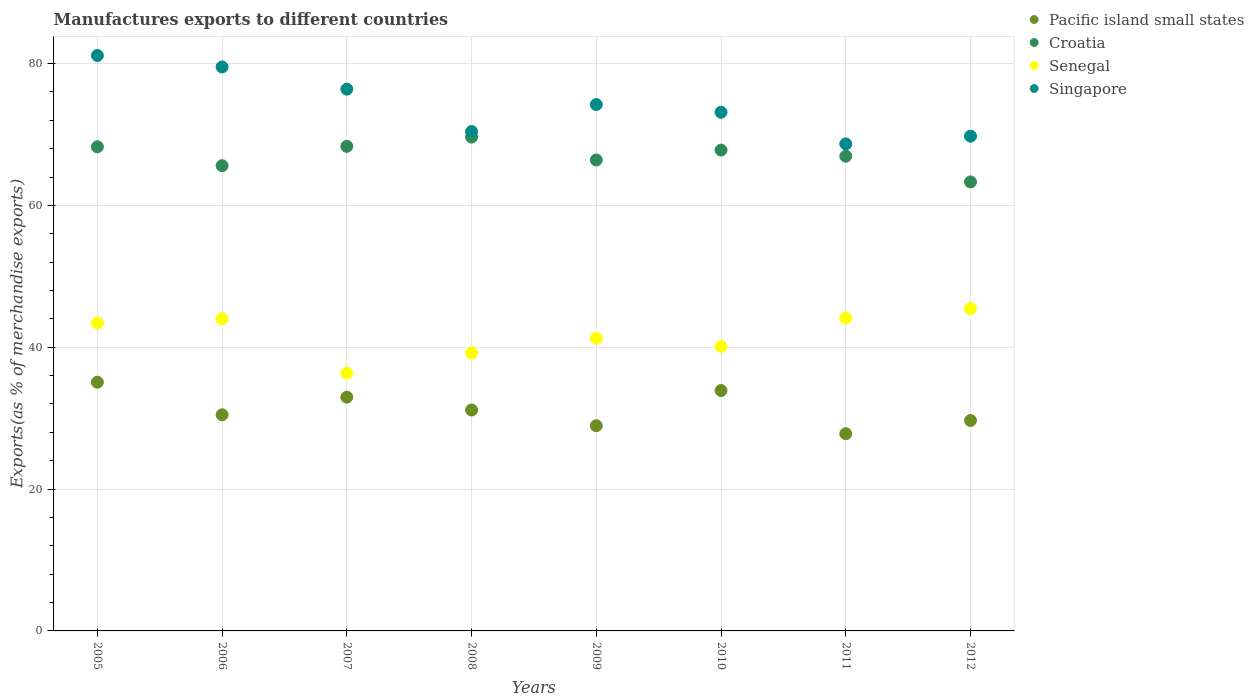How many different coloured dotlines are there?
Offer a very short reply. 4. Is the number of dotlines equal to the number of legend labels?
Offer a terse response. Yes. What is the percentage of exports to different countries in Singapore in 2008?
Make the answer very short. 70.42. Across all years, what is the maximum percentage of exports to different countries in Singapore?
Provide a short and direct response. 81.14. Across all years, what is the minimum percentage of exports to different countries in Senegal?
Make the answer very short. 36.35. What is the total percentage of exports to different countries in Croatia in the graph?
Your response must be concise. 536.26. What is the difference between the percentage of exports to different countries in Croatia in 2008 and that in 2011?
Ensure brevity in your answer.  2.69. What is the difference between the percentage of exports to different countries in Pacific island small states in 2006 and the percentage of exports to different countries in Senegal in 2012?
Provide a succinct answer. -14.97. What is the average percentage of exports to different countries in Croatia per year?
Offer a terse response. 67.03. In the year 2010, what is the difference between the percentage of exports to different countries in Singapore and percentage of exports to different countries in Pacific island small states?
Offer a very short reply. 39.23. What is the ratio of the percentage of exports to different countries in Singapore in 2007 to that in 2009?
Your response must be concise. 1.03. Is the percentage of exports to different countries in Pacific island small states in 2008 less than that in 2009?
Provide a short and direct response. No. What is the difference between the highest and the second highest percentage of exports to different countries in Singapore?
Make the answer very short. 1.62. What is the difference between the highest and the lowest percentage of exports to different countries in Pacific island small states?
Your answer should be very brief. 7.26. Is the sum of the percentage of exports to different countries in Singapore in 2006 and 2009 greater than the maximum percentage of exports to different countries in Pacific island small states across all years?
Ensure brevity in your answer.  Yes. Is it the case that in every year, the sum of the percentage of exports to different countries in Croatia and percentage of exports to different countries in Senegal  is greater than the sum of percentage of exports to different countries in Pacific island small states and percentage of exports to different countries in Singapore?
Offer a very short reply. Yes. Is it the case that in every year, the sum of the percentage of exports to different countries in Senegal and percentage of exports to different countries in Croatia  is greater than the percentage of exports to different countries in Singapore?
Provide a succinct answer. Yes. Is the percentage of exports to different countries in Pacific island small states strictly less than the percentage of exports to different countries in Croatia over the years?
Offer a very short reply. Yes. What is the difference between two consecutive major ticks on the Y-axis?
Your answer should be compact. 20. Are the values on the major ticks of Y-axis written in scientific E-notation?
Offer a terse response. No. Does the graph contain any zero values?
Offer a very short reply. No. Does the graph contain grids?
Offer a very short reply. Yes. How are the legend labels stacked?
Your answer should be very brief. Vertical. What is the title of the graph?
Offer a very short reply. Manufactures exports to different countries. What is the label or title of the X-axis?
Offer a very short reply. Years. What is the label or title of the Y-axis?
Ensure brevity in your answer.  Exports(as % of merchandise exports). What is the Exports(as % of merchandise exports) in Pacific island small states in 2005?
Your response must be concise. 35.07. What is the Exports(as % of merchandise exports) in Croatia in 2005?
Keep it short and to the point. 68.26. What is the Exports(as % of merchandise exports) of Senegal in 2005?
Offer a very short reply. 43.42. What is the Exports(as % of merchandise exports) of Singapore in 2005?
Offer a terse response. 81.14. What is the Exports(as % of merchandise exports) in Pacific island small states in 2006?
Offer a very short reply. 30.48. What is the Exports(as % of merchandise exports) of Croatia in 2006?
Offer a terse response. 65.6. What is the Exports(as % of merchandise exports) in Senegal in 2006?
Offer a terse response. 44.01. What is the Exports(as % of merchandise exports) of Singapore in 2006?
Your answer should be compact. 79.52. What is the Exports(as % of merchandise exports) of Pacific island small states in 2007?
Keep it short and to the point. 32.96. What is the Exports(as % of merchandise exports) of Croatia in 2007?
Your response must be concise. 68.32. What is the Exports(as % of merchandise exports) in Senegal in 2007?
Provide a short and direct response. 36.35. What is the Exports(as % of merchandise exports) of Singapore in 2007?
Provide a succinct answer. 76.39. What is the Exports(as % of merchandise exports) in Pacific island small states in 2008?
Your response must be concise. 31.14. What is the Exports(as % of merchandise exports) in Croatia in 2008?
Give a very brief answer. 69.63. What is the Exports(as % of merchandise exports) of Senegal in 2008?
Ensure brevity in your answer.  39.19. What is the Exports(as % of merchandise exports) of Singapore in 2008?
Provide a short and direct response. 70.42. What is the Exports(as % of merchandise exports) of Pacific island small states in 2009?
Ensure brevity in your answer.  28.94. What is the Exports(as % of merchandise exports) of Croatia in 2009?
Ensure brevity in your answer.  66.4. What is the Exports(as % of merchandise exports) of Senegal in 2009?
Your answer should be very brief. 41.28. What is the Exports(as % of merchandise exports) in Singapore in 2009?
Provide a short and direct response. 74.22. What is the Exports(as % of merchandise exports) of Pacific island small states in 2010?
Provide a succinct answer. 33.9. What is the Exports(as % of merchandise exports) of Croatia in 2010?
Offer a terse response. 67.8. What is the Exports(as % of merchandise exports) of Senegal in 2010?
Your answer should be compact. 40.12. What is the Exports(as % of merchandise exports) in Singapore in 2010?
Your answer should be very brief. 73.13. What is the Exports(as % of merchandise exports) in Pacific island small states in 2011?
Your response must be concise. 27.81. What is the Exports(as % of merchandise exports) of Croatia in 2011?
Ensure brevity in your answer.  66.94. What is the Exports(as % of merchandise exports) of Senegal in 2011?
Provide a succinct answer. 44.11. What is the Exports(as % of merchandise exports) in Singapore in 2011?
Offer a terse response. 68.67. What is the Exports(as % of merchandise exports) of Pacific island small states in 2012?
Your response must be concise. 29.67. What is the Exports(as % of merchandise exports) of Croatia in 2012?
Your answer should be compact. 63.31. What is the Exports(as % of merchandise exports) of Senegal in 2012?
Ensure brevity in your answer.  45.44. What is the Exports(as % of merchandise exports) of Singapore in 2012?
Your answer should be compact. 69.76. Across all years, what is the maximum Exports(as % of merchandise exports) in Pacific island small states?
Your response must be concise. 35.07. Across all years, what is the maximum Exports(as % of merchandise exports) of Croatia?
Your response must be concise. 69.63. Across all years, what is the maximum Exports(as % of merchandise exports) of Senegal?
Provide a short and direct response. 45.44. Across all years, what is the maximum Exports(as % of merchandise exports) of Singapore?
Make the answer very short. 81.14. Across all years, what is the minimum Exports(as % of merchandise exports) in Pacific island small states?
Keep it short and to the point. 27.81. Across all years, what is the minimum Exports(as % of merchandise exports) of Croatia?
Ensure brevity in your answer.  63.31. Across all years, what is the minimum Exports(as % of merchandise exports) in Senegal?
Your answer should be very brief. 36.35. Across all years, what is the minimum Exports(as % of merchandise exports) of Singapore?
Make the answer very short. 68.67. What is the total Exports(as % of merchandise exports) in Pacific island small states in the graph?
Keep it short and to the point. 249.96. What is the total Exports(as % of merchandise exports) of Croatia in the graph?
Your answer should be compact. 536.26. What is the total Exports(as % of merchandise exports) in Senegal in the graph?
Provide a short and direct response. 333.92. What is the total Exports(as % of merchandise exports) in Singapore in the graph?
Ensure brevity in your answer.  593.24. What is the difference between the Exports(as % of merchandise exports) of Pacific island small states in 2005 and that in 2006?
Offer a very short reply. 4.59. What is the difference between the Exports(as % of merchandise exports) of Croatia in 2005 and that in 2006?
Ensure brevity in your answer.  2.66. What is the difference between the Exports(as % of merchandise exports) of Senegal in 2005 and that in 2006?
Ensure brevity in your answer.  -0.59. What is the difference between the Exports(as % of merchandise exports) in Singapore in 2005 and that in 2006?
Your answer should be compact. 1.62. What is the difference between the Exports(as % of merchandise exports) in Pacific island small states in 2005 and that in 2007?
Offer a terse response. 2.11. What is the difference between the Exports(as % of merchandise exports) of Croatia in 2005 and that in 2007?
Offer a terse response. -0.06. What is the difference between the Exports(as % of merchandise exports) in Senegal in 2005 and that in 2007?
Your answer should be compact. 7.07. What is the difference between the Exports(as % of merchandise exports) in Singapore in 2005 and that in 2007?
Your answer should be very brief. 4.75. What is the difference between the Exports(as % of merchandise exports) in Pacific island small states in 2005 and that in 2008?
Give a very brief answer. 3.93. What is the difference between the Exports(as % of merchandise exports) of Croatia in 2005 and that in 2008?
Offer a very short reply. -1.37. What is the difference between the Exports(as % of merchandise exports) in Senegal in 2005 and that in 2008?
Provide a succinct answer. 4.24. What is the difference between the Exports(as % of merchandise exports) of Singapore in 2005 and that in 2008?
Offer a very short reply. 10.72. What is the difference between the Exports(as % of merchandise exports) in Pacific island small states in 2005 and that in 2009?
Provide a succinct answer. 6.13. What is the difference between the Exports(as % of merchandise exports) of Croatia in 2005 and that in 2009?
Your answer should be very brief. 1.86. What is the difference between the Exports(as % of merchandise exports) in Senegal in 2005 and that in 2009?
Your answer should be compact. 2.15. What is the difference between the Exports(as % of merchandise exports) of Singapore in 2005 and that in 2009?
Your answer should be very brief. 6.92. What is the difference between the Exports(as % of merchandise exports) in Pacific island small states in 2005 and that in 2010?
Your answer should be compact. 1.17. What is the difference between the Exports(as % of merchandise exports) in Croatia in 2005 and that in 2010?
Provide a succinct answer. 0.46. What is the difference between the Exports(as % of merchandise exports) in Senegal in 2005 and that in 2010?
Your answer should be compact. 3.31. What is the difference between the Exports(as % of merchandise exports) of Singapore in 2005 and that in 2010?
Provide a succinct answer. 8.01. What is the difference between the Exports(as % of merchandise exports) in Pacific island small states in 2005 and that in 2011?
Your answer should be compact. 7.26. What is the difference between the Exports(as % of merchandise exports) in Croatia in 2005 and that in 2011?
Your response must be concise. 1.32. What is the difference between the Exports(as % of merchandise exports) in Senegal in 2005 and that in 2011?
Your response must be concise. -0.69. What is the difference between the Exports(as % of merchandise exports) in Singapore in 2005 and that in 2011?
Your answer should be very brief. 12.47. What is the difference between the Exports(as % of merchandise exports) in Pacific island small states in 2005 and that in 2012?
Provide a short and direct response. 5.4. What is the difference between the Exports(as % of merchandise exports) in Croatia in 2005 and that in 2012?
Your answer should be very brief. 4.95. What is the difference between the Exports(as % of merchandise exports) of Senegal in 2005 and that in 2012?
Your response must be concise. -2.02. What is the difference between the Exports(as % of merchandise exports) of Singapore in 2005 and that in 2012?
Make the answer very short. 11.37. What is the difference between the Exports(as % of merchandise exports) in Pacific island small states in 2006 and that in 2007?
Offer a very short reply. -2.49. What is the difference between the Exports(as % of merchandise exports) of Croatia in 2006 and that in 2007?
Your answer should be compact. -2.72. What is the difference between the Exports(as % of merchandise exports) in Senegal in 2006 and that in 2007?
Make the answer very short. 7.66. What is the difference between the Exports(as % of merchandise exports) of Singapore in 2006 and that in 2007?
Your answer should be very brief. 3.13. What is the difference between the Exports(as % of merchandise exports) of Pacific island small states in 2006 and that in 2008?
Provide a succinct answer. -0.67. What is the difference between the Exports(as % of merchandise exports) of Croatia in 2006 and that in 2008?
Your answer should be very brief. -4.03. What is the difference between the Exports(as % of merchandise exports) in Senegal in 2006 and that in 2008?
Keep it short and to the point. 4.82. What is the difference between the Exports(as % of merchandise exports) of Singapore in 2006 and that in 2008?
Keep it short and to the point. 9.1. What is the difference between the Exports(as % of merchandise exports) in Pacific island small states in 2006 and that in 2009?
Your response must be concise. 1.54. What is the difference between the Exports(as % of merchandise exports) in Croatia in 2006 and that in 2009?
Provide a short and direct response. -0.8. What is the difference between the Exports(as % of merchandise exports) of Senegal in 2006 and that in 2009?
Offer a terse response. 2.73. What is the difference between the Exports(as % of merchandise exports) in Singapore in 2006 and that in 2009?
Offer a terse response. 5.3. What is the difference between the Exports(as % of merchandise exports) in Pacific island small states in 2006 and that in 2010?
Provide a succinct answer. -3.42. What is the difference between the Exports(as % of merchandise exports) in Croatia in 2006 and that in 2010?
Your response must be concise. -2.2. What is the difference between the Exports(as % of merchandise exports) in Senegal in 2006 and that in 2010?
Make the answer very short. 3.89. What is the difference between the Exports(as % of merchandise exports) of Singapore in 2006 and that in 2010?
Your answer should be compact. 6.39. What is the difference between the Exports(as % of merchandise exports) of Pacific island small states in 2006 and that in 2011?
Keep it short and to the point. 2.67. What is the difference between the Exports(as % of merchandise exports) in Croatia in 2006 and that in 2011?
Make the answer very short. -1.34. What is the difference between the Exports(as % of merchandise exports) of Senegal in 2006 and that in 2011?
Keep it short and to the point. -0.1. What is the difference between the Exports(as % of merchandise exports) of Singapore in 2006 and that in 2011?
Make the answer very short. 10.85. What is the difference between the Exports(as % of merchandise exports) of Pacific island small states in 2006 and that in 2012?
Provide a succinct answer. 0.81. What is the difference between the Exports(as % of merchandise exports) of Croatia in 2006 and that in 2012?
Provide a succinct answer. 2.29. What is the difference between the Exports(as % of merchandise exports) of Senegal in 2006 and that in 2012?
Your answer should be very brief. -1.44. What is the difference between the Exports(as % of merchandise exports) of Singapore in 2006 and that in 2012?
Provide a short and direct response. 9.76. What is the difference between the Exports(as % of merchandise exports) of Pacific island small states in 2007 and that in 2008?
Offer a very short reply. 1.82. What is the difference between the Exports(as % of merchandise exports) of Croatia in 2007 and that in 2008?
Your response must be concise. -1.3. What is the difference between the Exports(as % of merchandise exports) in Senegal in 2007 and that in 2008?
Your answer should be compact. -2.83. What is the difference between the Exports(as % of merchandise exports) in Singapore in 2007 and that in 2008?
Your response must be concise. 5.97. What is the difference between the Exports(as % of merchandise exports) in Pacific island small states in 2007 and that in 2009?
Provide a short and direct response. 4.02. What is the difference between the Exports(as % of merchandise exports) of Croatia in 2007 and that in 2009?
Your answer should be compact. 1.92. What is the difference between the Exports(as % of merchandise exports) in Senegal in 2007 and that in 2009?
Your response must be concise. -4.92. What is the difference between the Exports(as % of merchandise exports) of Singapore in 2007 and that in 2009?
Provide a succinct answer. 2.17. What is the difference between the Exports(as % of merchandise exports) of Pacific island small states in 2007 and that in 2010?
Offer a very short reply. -0.94. What is the difference between the Exports(as % of merchandise exports) in Croatia in 2007 and that in 2010?
Offer a terse response. 0.53. What is the difference between the Exports(as % of merchandise exports) in Senegal in 2007 and that in 2010?
Provide a short and direct response. -3.76. What is the difference between the Exports(as % of merchandise exports) of Singapore in 2007 and that in 2010?
Provide a short and direct response. 3.26. What is the difference between the Exports(as % of merchandise exports) in Pacific island small states in 2007 and that in 2011?
Provide a succinct answer. 5.16. What is the difference between the Exports(as % of merchandise exports) of Croatia in 2007 and that in 2011?
Give a very brief answer. 1.38. What is the difference between the Exports(as % of merchandise exports) in Senegal in 2007 and that in 2011?
Give a very brief answer. -7.76. What is the difference between the Exports(as % of merchandise exports) in Singapore in 2007 and that in 2011?
Your answer should be compact. 7.72. What is the difference between the Exports(as % of merchandise exports) in Pacific island small states in 2007 and that in 2012?
Offer a terse response. 3.3. What is the difference between the Exports(as % of merchandise exports) of Croatia in 2007 and that in 2012?
Your response must be concise. 5.01. What is the difference between the Exports(as % of merchandise exports) in Senegal in 2007 and that in 2012?
Your response must be concise. -9.09. What is the difference between the Exports(as % of merchandise exports) of Singapore in 2007 and that in 2012?
Provide a short and direct response. 6.63. What is the difference between the Exports(as % of merchandise exports) in Pacific island small states in 2008 and that in 2009?
Offer a very short reply. 2.21. What is the difference between the Exports(as % of merchandise exports) in Croatia in 2008 and that in 2009?
Give a very brief answer. 3.22. What is the difference between the Exports(as % of merchandise exports) of Senegal in 2008 and that in 2009?
Keep it short and to the point. -2.09. What is the difference between the Exports(as % of merchandise exports) in Singapore in 2008 and that in 2009?
Keep it short and to the point. -3.8. What is the difference between the Exports(as % of merchandise exports) in Pacific island small states in 2008 and that in 2010?
Provide a short and direct response. -2.75. What is the difference between the Exports(as % of merchandise exports) in Croatia in 2008 and that in 2010?
Your answer should be very brief. 1.83. What is the difference between the Exports(as % of merchandise exports) of Senegal in 2008 and that in 2010?
Your answer should be compact. -0.93. What is the difference between the Exports(as % of merchandise exports) of Singapore in 2008 and that in 2010?
Keep it short and to the point. -2.71. What is the difference between the Exports(as % of merchandise exports) of Pacific island small states in 2008 and that in 2011?
Your answer should be compact. 3.34. What is the difference between the Exports(as % of merchandise exports) of Croatia in 2008 and that in 2011?
Offer a very short reply. 2.69. What is the difference between the Exports(as % of merchandise exports) in Senegal in 2008 and that in 2011?
Offer a terse response. -4.92. What is the difference between the Exports(as % of merchandise exports) of Singapore in 2008 and that in 2011?
Give a very brief answer. 1.75. What is the difference between the Exports(as % of merchandise exports) in Pacific island small states in 2008 and that in 2012?
Your answer should be compact. 1.48. What is the difference between the Exports(as % of merchandise exports) in Croatia in 2008 and that in 2012?
Make the answer very short. 6.31. What is the difference between the Exports(as % of merchandise exports) of Senegal in 2008 and that in 2012?
Your answer should be compact. -6.26. What is the difference between the Exports(as % of merchandise exports) in Singapore in 2008 and that in 2012?
Your response must be concise. 0.66. What is the difference between the Exports(as % of merchandise exports) of Pacific island small states in 2009 and that in 2010?
Provide a short and direct response. -4.96. What is the difference between the Exports(as % of merchandise exports) of Croatia in 2009 and that in 2010?
Ensure brevity in your answer.  -1.39. What is the difference between the Exports(as % of merchandise exports) in Senegal in 2009 and that in 2010?
Make the answer very short. 1.16. What is the difference between the Exports(as % of merchandise exports) of Singapore in 2009 and that in 2010?
Offer a very short reply. 1.09. What is the difference between the Exports(as % of merchandise exports) of Pacific island small states in 2009 and that in 2011?
Provide a short and direct response. 1.13. What is the difference between the Exports(as % of merchandise exports) in Croatia in 2009 and that in 2011?
Keep it short and to the point. -0.54. What is the difference between the Exports(as % of merchandise exports) in Senegal in 2009 and that in 2011?
Ensure brevity in your answer.  -2.83. What is the difference between the Exports(as % of merchandise exports) in Singapore in 2009 and that in 2011?
Your answer should be very brief. 5.55. What is the difference between the Exports(as % of merchandise exports) in Pacific island small states in 2009 and that in 2012?
Your answer should be compact. -0.73. What is the difference between the Exports(as % of merchandise exports) of Croatia in 2009 and that in 2012?
Offer a very short reply. 3.09. What is the difference between the Exports(as % of merchandise exports) in Senegal in 2009 and that in 2012?
Provide a succinct answer. -4.17. What is the difference between the Exports(as % of merchandise exports) in Singapore in 2009 and that in 2012?
Make the answer very short. 4.46. What is the difference between the Exports(as % of merchandise exports) in Pacific island small states in 2010 and that in 2011?
Offer a very short reply. 6.09. What is the difference between the Exports(as % of merchandise exports) of Croatia in 2010 and that in 2011?
Offer a terse response. 0.86. What is the difference between the Exports(as % of merchandise exports) of Senegal in 2010 and that in 2011?
Provide a succinct answer. -3.99. What is the difference between the Exports(as % of merchandise exports) of Singapore in 2010 and that in 2011?
Your response must be concise. 4.46. What is the difference between the Exports(as % of merchandise exports) in Pacific island small states in 2010 and that in 2012?
Offer a terse response. 4.23. What is the difference between the Exports(as % of merchandise exports) in Croatia in 2010 and that in 2012?
Give a very brief answer. 4.49. What is the difference between the Exports(as % of merchandise exports) in Senegal in 2010 and that in 2012?
Provide a short and direct response. -5.33. What is the difference between the Exports(as % of merchandise exports) of Singapore in 2010 and that in 2012?
Make the answer very short. 3.37. What is the difference between the Exports(as % of merchandise exports) in Pacific island small states in 2011 and that in 2012?
Keep it short and to the point. -1.86. What is the difference between the Exports(as % of merchandise exports) in Croatia in 2011 and that in 2012?
Ensure brevity in your answer.  3.63. What is the difference between the Exports(as % of merchandise exports) of Senegal in 2011 and that in 2012?
Keep it short and to the point. -1.33. What is the difference between the Exports(as % of merchandise exports) of Singapore in 2011 and that in 2012?
Offer a very short reply. -1.09. What is the difference between the Exports(as % of merchandise exports) in Pacific island small states in 2005 and the Exports(as % of merchandise exports) in Croatia in 2006?
Give a very brief answer. -30.53. What is the difference between the Exports(as % of merchandise exports) in Pacific island small states in 2005 and the Exports(as % of merchandise exports) in Senegal in 2006?
Provide a succinct answer. -8.94. What is the difference between the Exports(as % of merchandise exports) of Pacific island small states in 2005 and the Exports(as % of merchandise exports) of Singapore in 2006?
Ensure brevity in your answer.  -44.45. What is the difference between the Exports(as % of merchandise exports) in Croatia in 2005 and the Exports(as % of merchandise exports) in Senegal in 2006?
Keep it short and to the point. 24.25. What is the difference between the Exports(as % of merchandise exports) in Croatia in 2005 and the Exports(as % of merchandise exports) in Singapore in 2006?
Provide a succinct answer. -11.26. What is the difference between the Exports(as % of merchandise exports) in Senegal in 2005 and the Exports(as % of merchandise exports) in Singapore in 2006?
Provide a succinct answer. -36.1. What is the difference between the Exports(as % of merchandise exports) in Pacific island small states in 2005 and the Exports(as % of merchandise exports) in Croatia in 2007?
Offer a very short reply. -33.25. What is the difference between the Exports(as % of merchandise exports) of Pacific island small states in 2005 and the Exports(as % of merchandise exports) of Senegal in 2007?
Your response must be concise. -1.28. What is the difference between the Exports(as % of merchandise exports) in Pacific island small states in 2005 and the Exports(as % of merchandise exports) in Singapore in 2007?
Give a very brief answer. -41.32. What is the difference between the Exports(as % of merchandise exports) in Croatia in 2005 and the Exports(as % of merchandise exports) in Senegal in 2007?
Provide a short and direct response. 31.91. What is the difference between the Exports(as % of merchandise exports) in Croatia in 2005 and the Exports(as % of merchandise exports) in Singapore in 2007?
Keep it short and to the point. -8.13. What is the difference between the Exports(as % of merchandise exports) in Senegal in 2005 and the Exports(as % of merchandise exports) in Singapore in 2007?
Offer a very short reply. -32.96. What is the difference between the Exports(as % of merchandise exports) of Pacific island small states in 2005 and the Exports(as % of merchandise exports) of Croatia in 2008?
Provide a succinct answer. -34.56. What is the difference between the Exports(as % of merchandise exports) in Pacific island small states in 2005 and the Exports(as % of merchandise exports) in Senegal in 2008?
Provide a short and direct response. -4.12. What is the difference between the Exports(as % of merchandise exports) of Pacific island small states in 2005 and the Exports(as % of merchandise exports) of Singapore in 2008?
Offer a very short reply. -35.35. What is the difference between the Exports(as % of merchandise exports) in Croatia in 2005 and the Exports(as % of merchandise exports) in Senegal in 2008?
Make the answer very short. 29.07. What is the difference between the Exports(as % of merchandise exports) of Croatia in 2005 and the Exports(as % of merchandise exports) of Singapore in 2008?
Offer a terse response. -2.16. What is the difference between the Exports(as % of merchandise exports) in Senegal in 2005 and the Exports(as % of merchandise exports) in Singapore in 2008?
Your answer should be very brief. -27. What is the difference between the Exports(as % of merchandise exports) of Pacific island small states in 2005 and the Exports(as % of merchandise exports) of Croatia in 2009?
Ensure brevity in your answer.  -31.33. What is the difference between the Exports(as % of merchandise exports) in Pacific island small states in 2005 and the Exports(as % of merchandise exports) in Senegal in 2009?
Offer a terse response. -6.21. What is the difference between the Exports(as % of merchandise exports) of Pacific island small states in 2005 and the Exports(as % of merchandise exports) of Singapore in 2009?
Keep it short and to the point. -39.15. What is the difference between the Exports(as % of merchandise exports) in Croatia in 2005 and the Exports(as % of merchandise exports) in Senegal in 2009?
Your answer should be very brief. 26.98. What is the difference between the Exports(as % of merchandise exports) in Croatia in 2005 and the Exports(as % of merchandise exports) in Singapore in 2009?
Make the answer very short. -5.96. What is the difference between the Exports(as % of merchandise exports) of Senegal in 2005 and the Exports(as % of merchandise exports) of Singapore in 2009?
Make the answer very short. -30.79. What is the difference between the Exports(as % of merchandise exports) in Pacific island small states in 2005 and the Exports(as % of merchandise exports) in Croatia in 2010?
Ensure brevity in your answer.  -32.73. What is the difference between the Exports(as % of merchandise exports) in Pacific island small states in 2005 and the Exports(as % of merchandise exports) in Senegal in 2010?
Your response must be concise. -5.05. What is the difference between the Exports(as % of merchandise exports) in Pacific island small states in 2005 and the Exports(as % of merchandise exports) in Singapore in 2010?
Provide a short and direct response. -38.06. What is the difference between the Exports(as % of merchandise exports) of Croatia in 2005 and the Exports(as % of merchandise exports) of Senegal in 2010?
Your response must be concise. 28.14. What is the difference between the Exports(as % of merchandise exports) in Croatia in 2005 and the Exports(as % of merchandise exports) in Singapore in 2010?
Your response must be concise. -4.87. What is the difference between the Exports(as % of merchandise exports) in Senegal in 2005 and the Exports(as % of merchandise exports) in Singapore in 2010?
Provide a short and direct response. -29.71. What is the difference between the Exports(as % of merchandise exports) of Pacific island small states in 2005 and the Exports(as % of merchandise exports) of Croatia in 2011?
Offer a terse response. -31.87. What is the difference between the Exports(as % of merchandise exports) in Pacific island small states in 2005 and the Exports(as % of merchandise exports) in Senegal in 2011?
Your response must be concise. -9.04. What is the difference between the Exports(as % of merchandise exports) in Pacific island small states in 2005 and the Exports(as % of merchandise exports) in Singapore in 2011?
Provide a succinct answer. -33.6. What is the difference between the Exports(as % of merchandise exports) in Croatia in 2005 and the Exports(as % of merchandise exports) in Senegal in 2011?
Offer a very short reply. 24.15. What is the difference between the Exports(as % of merchandise exports) in Croatia in 2005 and the Exports(as % of merchandise exports) in Singapore in 2011?
Give a very brief answer. -0.41. What is the difference between the Exports(as % of merchandise exports) in Senegal in 2005 and the Exports(as % of merchandise exports) in Singapore in 2011?
Provide a succinct answer. -25.25. What is the difference between the Exports(as % of merchandise exports) in Pacific island small states in 2005 and the Exports(as % of merchandise exports) in Croatia in 2012?
Your answer should be very brief. -28.24. What is the difference between the Exports(as % of merchandise exports) in Pacific island small states in 2005 and the Exports(as % of merchandise exports) in Senegal in 2012?
Offer a very short reply. -10.37. What is the difference between the Exports(as % of merchandise exports) of Pacific island small states in 2005 and the Exports(as % of merchandise exports) of Singapore in 2012?
Make the answer very short. -34.69. What is the difference between the Exports(as % of merchandise exports) in Croatia in 2005 and the Exports(as % of merchandise exports) in Senegal in 2012?
Provide a succinct answer. 22.81. What is the difference between the Exports(as % of merchandise exports) in Croatia in 2005 and the Exports(as % of merchandise exports) in Singapore in 2012?
Give a very brief answer. -1.5. What is the difference between the Exports(as % of merchandise exports) in Senegal in 2005 and the Exports(as % of merchandise exports) in Singapore in 2012?
Offer a terse response. -26.34. What is the difference between the Exports(as % of merchandise exports) in Pacific island small states in 2006 and the Exports(as % of merchandise exports) in Croatia in 2007?
Ensure brevity in your answer.  -37.85. What is the difference between the Exports(as % of merchandise exports) of Pacific island small states in 2006 and the Exports(as % of merchandise exports) of Senegal in 2007?
Provide a succinct answer. -5.88. What is the difference between the Exports(as % of merchandise exports) of Pacific island small states in 2006 and the Exports(as % of merchandise exports) of Singapore in 2007?
Provide a succinct answer. -45.91. What is the difference between the Exports(as % of merchandise exports) of Croatia in 2006 and the Exports(as % of merchandise exports) of Senegal in 2007?
Provide a succinct answer. 29.25. What is the difference between the Exports(as % of merchandise exports) of Croatia in 2006 and the Exports(as % of merchandise exports) of Singapore in 2007?
Make the answer very short. -10.79. What is the difference between the Exports(as % of merchandise exports) in Senegal in 2006 and the Exports(as % of merchandise exports) in Singapore in 2007?
Offer a terse response. -32.38. What is the difference between the Exports(as % of merchandise exports) in Pacific island small states in 2006 and the Exports(as % of merchandise exports) in Croatia in 2008?
Give a very brief answer. -39.15. What is the difference between the Exports(as % of merchandise exports) of Pacific island small states in 2006 and the Exports(as % of merchandise exports) of Senegal in 2008?
Offer a terse response. -8.71. What is the difference between the Exports(as % of merchandise exports) of Pacific island small states in 2006 and the Exports(as % of merchandise exports) of Singapore in 2008?
Offer a very short reply. -39.94. What is the difference between the Exports(as % of merchandise exports) in Croatia in 2006 and the Exports(as % of merchandise exports) in Senegal in 2008?
Ensure brevity in your answer.  26.41. What is the difference between the Exports(as % of merchandise exports) in Croatia in 2006 and the Exports(as % of merchandise exports) in Singapore in 2008?
Ensure brevity in your answer.  -4.82. What is the difference between the Exports(as % of merchandise exports) of Senegal in 2006 and the Exports(as % of merchandise exports) of Singapore in 2008?
Offer a very short reply. -26.41. What is the difference between the Exports(as % of merchandise exports) of Pacific island small states in 2006 and the Exports(as % of merchandise exports) of Croatia in 2009?
Your response must be concise. -35.93. What is the difference between the Exports(as % of merchandise exports) of Pacific island small states in 2006 and the Exports(as % of merchandise exports) of Senegal in 2009?
Make the answer very short. -10.8. What is the difference between the Exports(as % of merchandise exports) in Pacific island small states in 2006 and the Exports(as % of merchandise exports) in Singapore in 2009?
Ensure brevity in your answer.  -43.74. What is the difference between the Exports(as % of merchandise exports) in Croatia in 2006 and the Exports(as % of merchandise exports) in Senegal in 2009?
Offer a terse response. 24.32. What is the difference between the Exports(as % of merchandise exports) in Croatia in 2006 and the Exports(as % of merchandise exports) in Singapore in 2009?
Give a very brief answer. -8.62. What is the difference between the Exports(as % of merchandise exports) of Senegal in 2006 and the Exports(as % of merchandise exports) of Singapore in 2009?
Give a very brief answer. -30.21. What is the difference between the Exports(as % of merchandise exports) of Pacific island small states in 2006 and the Exports(as % of merchandise exports) of Croatia in 2010?
Your answer should be very brief. -37.32. What is the difference between the Exports(as % of merchandise exports) of Pacific island small states in 2006 and the Exports(as % of merchandise exports) of Senegal in 2010?
Your answer should be very brief. -9.64. What is the difference between the Exports(as % of merchandise exports) in Pacific island small states in 2006 and the Exports(as % of merchandise exports) in Singapore in 2010?
Keep it short and to the point. -42.65. What is the difference between the Exports(as % of merchandise exports) in Croatia in 2006 and the Exports(as % of merchandise exports) in Senegal in 2010?
Make the answer very short. 25.48. What is the difference between the Exports(as % of merchandise exports) in Croatia in 2006 and the Exports(as % of merchandise exports) in Singapore in 2010?
Your response must be concise. -7.53. What is the difference between the Exports(as % of merchandise exports) in Senegal in 2006 and the Exports(as % of merchandise exports) in Singapore in 2010?
Offer a very short reply. -29.12. What is the difference between the Exports(as % of merchandise exports) of Pacific island small states in 2006 and the Exports(as % of merchandise exports) of Croatia in 2011?
Give a very brief answer. -36.46. What is the difference between the Exports(as % of merchandise exports) of Pacific island small states in 2006 and the Exports(as % of merchandise exports) of Senegal in 2011?
Your answer should be compact. -13.63. What is the difference between the Exports(as % of merchandise exports) of Pacific island small states in 2006 and the Exports(as % of merchandise exports) of Singapore in 2011?
Provide a short and direct response. -38.19. What is the difference between the Exports(as % of merchandise exports) in Croatia in 2006 and the Exports(as % of merchandise exports) in Senegal in 2011?
Provide a short and direct response. 21.49. What is the difference between the Exports(as % of merchandise exports) in Croatia in 2006 and the Exports(as % of merchandise exports) in Singapore in 2011?
Ensure brevity in your answer.  -3.07. What is the difference between the Exports(as % of merchandise exports) of Senegal in 2006 and the Exports(as % of merchandise exports) of Singapore in 2011?
Keep it short and to the point. -24.66. What is the difference between the Exports(as % of merchandise exports) of Pacific island small states in 2006 and the Exports(as % of merchandise exports) of Croatia in 2012?
Provide a short and direct response. -32.84. What is the difference between the Exports(as % of merchandise exports) of Pacific island small states in 2006 and the Exports(as % of merchandise exports) of Senegal in 2012?
Give a very brief answer. -14.97. What is the difference between the Exports(as % of merchandise exports) of Pacific island small states in 2006 and the Exports(as % of merchandise exports) of Singapore in 2012?
Keep it short and to the point. -39.29. What is the difference between the Exports(as % of merchandise exports) of Croatia in 2006 and the Exports(as % of merchandise exports) of Senegal in 2012?
Provide a short and direct response. 20.16. What is the difference between the Exports(as % of merchandise exports) of Croatia in 2006 and the Exports(as % of merchandise exports) of Singapore in 2012?
Keep it short and to the point. -4.16. What is the difference between the Exports(as % of merchandise exports) of Senegal in 2006 and the Exports(as % of merchandise exports) of Singapore in 2012?
Keep it short and to the point. -25.75. What is the difference between the Exports(as % of merchandise exports) of Pacific island small states in 2007 and the Exports(as % of merchandise exports) of Croatia in 2008?
Keep it short and to the point. -36.67. What is the difference between the Exports(as % of merchandise exports) in Pacific island small states in 2007 and the Exports(as % of merchandise exports) in Senegal in 2008?
Offer a terse response. -6.22. What is the difference between the Exports(as % of merchandise exports) of Pacific island small states in 2007 and the Exports(as % of merchandise exports) of Singapore in 2008?
Provide a succinct answer. -37.46. What is the difference between the Exports(as % of merchandise exports) in Croatia in 2007 and the Exports(as % of merchandise exports) in Senegal in 2008?
Keep it short and to the point. 29.14. What is the difference between the Exports(as % of merchandise exports) in Croatia in 2007 and the Exports(as % of merchandise exports) in Singapore in 2008?
Make the answer very short. -2.1. What is the difference between the Exports(as % of merchandise exports) in Senegal in 2007 and the Exports(as % of merchandise exports) in Singapore in 2008?
Offer a very short reply. -34.07. What is the difference between the Exports(as % of merchandise exports) of Pacific island small states in 2007 and the Exports(as % of merchandise exports) of Croatia in 2009?
Provide a short and direct response. -33.44. What is the difference between the Exports(as % of merchandise exports) of Pacific island small states in 2007 and the Exports(as % of merchandise exports) of Senegal in 2009?
Offer a terse response. -8.32. What is the difference between the Exports(as % of merchandise exports) in Pacific island small states in 2007 and the Exports(as % of merchandise exports) in Singapore in 2009?
Your response must be concise. -41.26. What is the difference between the Exports(as % of merchandise exports) in Croatia in 2007 and the Exports(as % of merchandise exports) in Senegal in 2009?
Your answer should be compact. 27.05. What is the difference between the Exports(as % of merchandise exports) in Croatia in 2007 and the Exports(as % of merchandise exports) in Singapore in 2009?
Keep it short and to the point. -5.89. What is the difference between the Exports(as % of merchandise exports) of Senegal in 2007 and the Exports(as % of merchandise exports) of Singapore in 2009?
Offer a terse response. -37.86. What is the difference between the Exports(as % of merchandise exports) in Pacific island small states in 2007 and the Exports(as % of merchandise exports) in Croatia in 2010?
Provide a succinct answer. -34.84. What is the difference between the Exports(as % of merchandise exports) in Pacific island small states in 2007 and the Exports(as % of merchandise exports) in Senegal in 2010?
Make the answer very short. -7.16. What is the difference between the Exports(as % of merchandise exports) of Pacific island small states in 2007 and the Exports(as % of merchandise exports) of Singapore in 2010?
Ensure brevity in your answer.  -40.17. What is the difference between the Exports(as % of merchandise exports) of Croatia in 2007 and the Exports(as % of merchandise exports) of Senegal in 2010?
Provide a short and direct response. 28.21. What is the difference between the Exports(as % of merchandise exports) in Croatia in 2007 and the Exports(as % of merchandise exports) in Singapore in 2010?
Provide a short and direct response. -4.81. What is the difference between the Exports(as % of merchandise exports) in Senegal in 2007 and the Exports(as % of merchandise exports) in Singapore in 2010?
Your answer should be compact. -36.78. What is the difference between the Exports(as % of merchandise exports) of Pacific island small states in 2007 and the Exports(as % of merchandise exports) of Croatia in 2011?
Offer a terse response. -33.98. What is the difference between the Exports(as % of merchandise exports) of Pacific island small states in 2007 and the Exports(as % of merchandise exports) of Senegal in 2011?
Ensure brevity in your answer.  -11.15. What is the difference between the Exports(as % of merchandise exports) of Pacific island small states in 2007 and the Exports(as % of merchandise exports) of Singapore in 2011?
Make the answer very short. -35.71. What is the difference between the Exports(as % of merchandise exports) in Croatia in 2007 and the Exports(as % of merchandise exports) in Senegal in 2011?
Ensure brevity in your answer.  24.21. What is the difference between the Exports(as % of merchandise exports) of Croatia in 2007 and the Exports(as % of merchandise exports) of Singapore in 2011?
Offer a terse response. -0.35. What is the difference between the Exports(as % of merchandise exports) of Senegal in 2007 and the Exports(as % of merchandise exports) of Singapore in 2011?
Provide a succinct answer. -32.32. What is the difference between the Exports(as % of merchandise exports) of Pacific island small states in 2007 and the Exports(as % of merchandise exports) of Croatia in 2012?
Make the answer very short. -30.35. What is the difference between the Exports(as % of merchandise exports) of Pacific island small states in 2007 and the Exports(as % of merchandise exports) of Senegal in 2012?
Keep it short and to the point. -12.48. What is the difference between the Exports(as % of merchandise exports) in Pacific island small states in 2007 and the Exports(as % of merchandise exports) in Singapore in 2012?
Your answer should be compact. -36.8. What is the difference between the Exports(as % of merchandise exports) of Croatia in 2007 and the Exports(as % of merchandise exports) of Senegal in 2012?
Offer a terse response. 22.88. What is the difference between the Exports(as % of merchandise exports) in Croatia in 2007 and the Exports(as % of merchandise exports) in Singapore in 2012?
Offer a terse response. -1.44. What is the difference between the Exports(as % of merchandise exports) in Senegal in 2007 and the Exports(as % of merchandise exports) in Singapore in 2012?
Your answer should be very brief. -33.41. What is the difference between the Exports(as % of merchandise exports) in Pacific island small states in 2008 and the Exports(as % of merchandise exports) in Croatia in 2009?
Give a very brief answer. -35.26. What is the difference between the Exports(as % of merchandise exports) of Pacific island small states in 2008 and the Exports(as % of merchandise exports) of Senegal in 2009?
Provide a short and direct response. -10.13. What is the difference between the Exports(as % of merchandise exports) in Pacific island small states in 2008 and the Exports(as % of merchandise exports) in Singapore in 2009?
Give a very brief answer. -43.07. What is the difference between the Exports(as % of merchandise exports) in Croatia in 2008 and the Exports(as % of merchandise exports) in Senegal in 2009?
Your answer should be compact. 28.35. What is the difference between the Exports(as % of merchandise exports) of Croatia in 2008 and the Exports(as % of merchandise exports) of Singapore in 2009?
Your response must be concise. -4.59. What is the difference between the Exports(as % of merchandise exports) of Senegal in 2008 and the Exports(as % of merchandise exports) of Singapore in 2009?
Make the answer very short. -35.03. What is the difference between the Exports(as % of merchandise exports) of Pacific island small states in 2008 and the Exports(as % of merchandise exports) of Croatia in 2010?
Provide a short and direct response. -36.65. What is the difference between the Exports(as % of merchandise exports) in Pacific island small states in 2008 and the Exports(as % of merchandise exports) in Senegal in 2010?
Your answer should be compact. -8.97. What is the difference between the Exports(as % of merchandise exports) of Pacific island small states in 2008 and the Exports(as % of merchandise exports) of Singapore in 2010?
Provide a succinct answer. -41.99. What is the difference between the Exports(as % of merchandise exports) of Croatia in 2008 and the Exports(as % of merchandise exports) of Senegal in 2010?
Offer a very short reply. 29.51. What is the difference between the Exports(as % of merchandise exports) of Croatia in 2008 and the Exports(as % of merchandise exports) of Singapore in 2010?
Give a very brief answer. -3.5. What is the difference between the Exports(as % of merchandise exports) of Senegal in 2008 and the Exports(as % of merchandise exports) of Singapore in 2010?
Make the answer very short. -33.94. What is the difference between the Exports(as % of merchandise exports) in Pacific island small states in 2008 and the Exports(as % of merchandise exports) in Croatia in 2011?
Your answer should be compact. -35.8. What is the difference between the Exports(as % of merchandise exports) of Pacific island small states in 2008 and the Exports(as % of merchandise exports) of Senegal in 2011?
Your answer should be compact. -12.97. What is the difference between the Exports(as % of merchandise exports) of Pacific island small states in 2008 and the Exports(as % of merchandise exports) of Singapore in 2011?
Provide a succinct answer. -37.53. What is the difference between the Exports(as % of merchandise exports) in Croatia in 2008 and the Exports(as % of merchandise exports) in Senegal in 2011?
Give a very brief answer. 25.52. What is the difference between the Exports(as % of merchandise exports) in Croatia in 2008 and the Exports(as % of merchandise exports) in Singapore in 2011?
Offer a terse response. 0.96. What is the difference between the Exports(as % of merchandise exports) in Senegal in 2008 and the Exports(as % of merchandise exports) in Singapore in 2011?
Provide a short and direct response. -29.48. What is the difference between the Exports(as % of merchandise exports) in Pacific island small states in 2008 and the Exports(as % of merchandise exports) in Croatia in 2012?
Your answer should be compact. -32.17. What is the difference between the Exports(as % of merchandise exports) in Pacific island small states in 2008 and the Exports(as % of merchandise exports) in Senegal in 2012?
Give a very brief answer. -14.3. What is the difference between the Exports(as % of merchandise exports) in Pacific island small states in 2008 and the Exports(as % of merchandise exports) in Singapore in 2012?
Make the answer very short. -38.62. What is the difference between the Exports(as % of merchandise exports) of Croatia in 2008 and the Exports(as % of merchandise exports) of Senegal in 2012?
Provide a short and direct response. 24.18. What is the difference between the Exports(as % of merchandise exports) of Croatia in 2008 and the Exports(as % of merchandise exports) of Singapore in 2012?
Ensure brevity in your answer.  -0.14. What is the difference between the Exports(as % of merchandise exports) in Senegal in 2008 and the Exports(as % of merchandise exports) in Singapore in 2012?
Your answer should be compact. -30.58. What is the difference between the Exports(as % of merchandise exports) of Pacific island small states in 2009 and the Exports(as % of merchandise exports) of Croatia in 2010?
Your answer should be compact. -38.86. What is the difference between the Exports(as % of merchandise exports) in Pacific island small states in 2009 and the Exports(as % of merchandise exports) in Senegal in 2010?
Your response must be concise. -11.18. What is the difference between the Exports(as % of merchandise exports) in Pacific island small states in 2009 and the Exports(as % of merchandise exports) in Singapore in 2010?
Provide a short and direct response. -44.19. What is the difference between the Exports(as % of merchandise exports) of Croatia in 2009 and the Exports(as % of merchandise exports) of Senegal in 2010?
Provide a succinct answer. 26.29. What is the difference between the Exports(as % of merchandise exports) of Croatia in 2009 and the Exports(as % of merchandise exports) of Singapore in 2010?
Your answer should be compact. -6.73. What is the difference between the Exports(as % of merchandise exports) in Senegal in 2009 and the Exports(as % of merchandise exports) in Singapore in 2010?
Your response must be concise. -31.85. What is the difference between the Exports(as % of merchandise exports) in Pacific island small states in 2009 and the Exports(as % of merchandise exports) in Croatia in 2011?
Offer a terse response. -38. What is the difference between the Exports(as % of merchandise exports) of Pacific island small states in 2009 and the Exports(as % of merchandise exports) of Senegal in 2011?
Provide a succinct answer. -15.17. What is the difference between the Exports(as % of merchandise exports) of Pacific island small states in 2009 and the Exports(as % of merchandise exports) of Singapore in 2011?
Your answer should be very brief. -39.73. What is the difference between the Exports(as % of merchandise exports) of Croatia in 2009 and the Exports(as % of merchandise exports) of Senegal in 2011?
Offer a very short reply. 22.29. What is the difference between the Exports(as % of merchandise exports) of Croatia in 2009 and the Exports(as % of merchandise exports) of Singapore in 2011?
Ensure brevity in your answer.  -2.27. What is the difference between the Exports(as % of merchandise exports) in Senegal in 2009 and the Exports(as % of merchandise exports) in Singapore in 2011?
Your answer should be compact. -27.39. What is the difference between the Exports(as % of merchandise exports) in Pacific island small states in 2009 and the Exports(as % of merchandise exports) in Croatia in 2012?
Offer a terse response. -34.38. What is the difference between the Exports(as % of merchandise exports) in Pacific island small states in 2009 and the Exports(as % of merchandise exports) in Senegal in 2012?
Provide a succinct answer. -16.51. What is the difference between the Exports(as % of merchandise exports) of Pacific island small states in 2009 and the Exports(as % of merchandise exports) of Singapore in 2012?
Provide a succinct answer. -40.83. What is the difference between the Exports(as % of merchandise exports) of Croatia in 2009 and the Exports(as % of merchandise exports) of Senegal in 2012?
Give a very brief answer. 20.96. What is the difference between the Exports(as % of merchandise exports) of Croatia in 2009 and the Exports(as % of merchandise exports) of Singapore in 2012?
Provide a succinct answer. -3.36. What is the difference between the Exports(as % of merchandise exports) of Senegal in 2009 and the Exports(as % of merchandise exports) of Singapore in 2012?
Ensure brevity in your answer.  -28.49. What is the difference between the Exports(as % of merchandise exports) in Pacific island small states in 2010 and the Exports(as % of merchandise exports) in Croatia in 2011?
Your answer should be very brief. -33.04. What is the difference between the Exports(as % of merchandise exports) in Pacific island small states in 2010 and the Exports(as % of merchandise exports) in Senegal in 2011?
Make the answer very short. -10.21. What is the difference between the Exports(as % of merchandise exports) of Pacific island small states in 2010 and the Exports(as % of merchandise exports) of Singapore in 2011?
Keep it short and to the point. -34.77. What is the difference between the Exports(as % of merchandise exports) of Croatia in 2010 and the Exports(as % of merchandise exports) of Senegal in 2011?
Keep it short and to the point. 23.69. What is the difference between the Exports(as % of merchandise exports) of Croatia in 2010 and the Exports(as % of merchandise exports) of Singapore in 2011?
Offer a very short reply. -0.87. What is the difference between the Exports(as % of merchandise exports) in Senegal in 2010 and the Exports(as % of merchandise exports) in Singapore in 2011?
Make the answer very short. -28.55. What is the difference between the Exports(as % of merchandise exports) of Pacific island small states in 2010 and the Exports(as % of merchandise exports) of Croatia in 2012?
Offer a terse response. -29.41. What is the difference between the Exports(as % of merchandise exports) in Pacific island small states in 2010 and the Exports(as % of merchandise exports) in Senegal in 2012?
Your answer should be very brief. -11.55. What is the difference between the Exports(as % of merchandise exports) of Pacific island small states in 2010 and the Exports(as % of merchandise exports) of Singapore in 2012?
Your answer should be compact. -35.86. What is the difference between the Exports(as % of merchandise exports) in Croatia in 2010 and the Exports(as % of merchandise exports) in Senegal in 2012?
Ensure brevity in your answer.  22.35. What is the difference between the Exports(as % of merchandise exports) of Croatia in 2010 and the Exports(as % of merchandise exports) of Singapore in 2012?
Keep it short and to the point. -1.96. What is the difference between the Exports(as % of merchandise exports) of Senegal in 2010 and the Exports(as % of merchandise exports) of Singapore in 2012?
Give a very brief answer. -29.65. What is the difference between the Exports(as % of merchandise exports) of Pacific island small states in 2011 and the Exports(as % of merchandise exports) of Croatia in 2012?
Your answer should be very brief. -35.51. What is the difference between the Exports(as % of merchandise exports) of Pacific island small states in 2011 and the Exports(as % of merchandise exports) of Senegal in 2012?
Provide a short and direct response. -17.64. What is the difference between the Exports(as % of merchandise exports) in Pacific island small states in 2011 and the Exports(as % of merchandise exports) in Singapore in 2012?
Offer a very short reply. -41.96. What is the difference between the Exports(as % of merchandise exports) of Croatia in 2011 and the Exports(as % of merchandise exports) of Senegal in 2012?
Offer a very short reply. 21.5. What is the difference between the Exports(as % of merchandise exports) in Croatia in 2011 and the Exports(as % of merchandise exports) in Singapore in 2012?
Provide a short and direct response. -2.82. What is the difference between the Exports(as % of merchandise exports) in Senegal in 2011 and the Exports(as % of merchandise exports) in Singapore in 2012?
Your answer should be compact. -25.65. What is the average Exports(as % of merchandise exports) of Pacific island small states per year?
Offer a very short reply. 31.24. What is the average Exports(as % of merchandise exports) in Croatia per year?
Keep it short and to the point. 67.03. What is the average Exports(as % of merchandise exports) in Senegal per year?
Keep it short and to the point. 41.74. What is the average Exports(as % of merchandise exports) of Singapore per year?
Your response must be concise. 74.15. In the year 2005, what is the difference between the Exports(as % of merchandise exports) of Pacific island small states and Exports(as % of merchandise exports) of Croatia?
Give a very brief answer. -33.19. In the year 2005, what is the difference between the Exports(as % of merchandise exports) of Pacific island small states and Exports(as % of merchandise exports) of Senegal?
Give a very brief answer. -8.35. In the year 2005, what is the difference between the Exports(as % of merchandise exports) of Pacific island small states and Exports(as % of merchandise exports) of Singapore?
Make the answer very short. -46.07. In the year 2005, what is the difference between the Exports(as % of merchandise exports) of Croatia and Exports(as % of merchandise exports) of Senegal?
Make the answer very short. 24.84. In the year 2005, what is the difference between the Exports(as % of merchandise exports) in Croatia and Exports(as % of merchandise exports) in Singapore?
Ensure brevity in your answer.  -12.88. In the year 2005, what is the difference between the Exports(as % of merchandise exports) in Senegal and Exports(as % of merchandise exports) in Singapore?
Your answer should be very brief. -37.71. In the year 2006, what is the difference between the Exports(as % of merchandise exports) of Pacific island small states and Exports(as % of merchandise exports) of Croatia?
Offer a terse response. -35.12. In the year 2006, what is the difference between the Exports(as % of merchandise exports) of Pacific island small states and Exports(as % of merchandise exports) of Senegal?
Provide a short and direct response. -13.53. In the year 2006, what is the difference between the Exports(as % of merchandise exports) in Pacific island small states and Exports(as % of merchandise exports) in Singapore?
Provide a short and direct response. -49.04. In the year 2006, what is the difference between the Exports(as % of merchandise exports) of Croatia and Exports(as % of merchandise exports) of Senegal?
Provide a short and direct response. 21.59. In the year 2006, what is the difference between the Exports(as % of merchandise exports) in Croatia and Exports(as % of merchandise exports) in Singapore?
Keep it short and to the point. -13.92. In the year 2006, what is the difference between the Exports(as % of merchandise exports) in Senegal and Exports(as % of merchandise exports) in Singapore?
Ensure brevity in your answer.  -35.51. In the year 2007, what is the difference between the Exports(as % of merchandise exports) of Pacific island small states and Exports(as % of merchandise exports) of Croatia?
Provide a short and direct response. -35.36. In the year 2007, what is the difference between the Exports(as % of merchandise exports) of Pacific island small states and Exports(as % of merchandise exports) of Senegal?
Your answer should be compact. -3.39. In the year 2007, what is the difference between the Exports(as % of merchandise exports) of Pacific island small states and Exports(as % of merchandise exports) of Singapore?
Your answer should be compact. -43.43. In the year 2007, what is the difference between the Exports(as % of merchandise exports) of Croatia and Exports(as % of merchandise exports) of Senegal?
Keep it short and to the point. 31.97. In the year 2007, what is the difference between the Exports(as % of merchandise exports) in Croatia and Exports(as % of merchandise exports) in Singapore?
Offer a very short reply. -8.06. In the year 2007, what is the difference between the Exports(as % of merchandise exports) in Senegal and Exports(as % of merchandise exports) in Singapore?
Offer a terse response. -40.03. In the year 2008, what is the difference between the Exports(as % of merchandise exports) in Pacific island small states and Exports(as % of merchandise exports) in Croatia?
Keep it short and to the point. -38.48. In the year 2008, what is the difference between the Exports(as % of merchandise exports) in Pacific island small states and Exports(as % of merchandise exports) in Senegal?
Make the answer very short. -8.04. In the year 2008, what is the difference between the Exports(as % of merchandise exports) in Pacific island small states and Exports(as % of merchandise exports) in Singapore?
Make the answer very short. -39.28. In the year 2008, what is the difference between the Exports(as % of merchandise exports) in Croatia and Exports(as % of merchandise exports) in Senegal?
Make the answer very short. 30.44. In the year 2008, what is the difference between the Exports(as % of merchandise exports) of Croatia and Exports(as % of merchandise exports) of Singapore?
Ensure brevity in your answer.  -0.79. In the year 2008, what is the difference between the Exports(as % of merchandise exports) of Senegal and Exports(as % of merchandise exports) of Singapore?
Offer a very short reply. -31.23. In the year 2009, what is the difference between the Exports(as % of merchandise exports) in Pacific island small states and Exports(as % of merchandise exports) in Croatia?
Ensure brevity in your answer.  -37.47. In the year 2009, what is the difference between the Exports(as % of merchandise exports) of Pacific island small states and Exports(as % of merchandise exports) of Senegal?
Your response must be concise. -12.34. In the year 2009, what is the difference between the Exports(as % of merchandise exports) of Pacific island small states and Exports(as % of merchandise exports) of Singapore?
Provide a succinct answer. -45.28. In the year 2009, what is the difference between the Exports(as % of merchandise exports) in Croatia and Exports(as % of merchandise exports) in Senegal?
Keep it short and to the point. 25.13. In the year 2009, what is the difference between the Exports(as % of merchandise exports) of Croatia and Exports(as % of merchandise exports) of Singapore?
Ensure brevity in your answer.  -7.81. In the year 2009, what is the difference between the Exports(as % of merchandise exports) in Senegal and Exports(as % of merchandise exports) in Singapore?
Your answer should be very brief. -32.94. In the year 2010, what is the difference between the Exports(as % of merchandise exports) in Pacific island small states and Exports(as % of merchandise exports) in Croatia?
Provide a short and direct response. -33.9. In the year 2010, what is the difference between the Exports(as % of merchandise exports) of Pacific island small states and Exports(as % of merchandise exports) of Senegal?
Offer a terse response. -6.22. In the year 2010, what is the difference between the Exports(as % of merchandise exports) of Pacific island small states and Exports(as % of merchandise exports) of Singapore?
Offer a terse response. -39.23. In the year 2010, what is the difference between the Exports(as % of merchandise exports) in Croatia and Exports(as % of merchandise exports) in Senegal?
Provide a short and direct response. 27.68. In the year 2010, what is the difference between the Exports(as % of merchandise exports) of Croatia and Exports(as % of merchandise exports) of Singapore?
Offer a terse response. -5.33. In the year 2010, what is the difference between the Exports(as % of merchandise exports) in Senegal and Exports(as % of merchandise exports) in Singapore?
Provide a short and direct response. -33.01. In the year 2011, what is the difference between the Exports(as % of merchandise exports) in Pacific island small states and Exports(as % of merchandise exports) in Croatia?
Provide a short and direct response. -39.13. In the year 2011, what is the difference between the Exports(as % of merchandise exports) in Pacific island small states and Exports(as % of merchandise exports) in Senegal?
Your answer should be compact. -16.3. In the year 2011, what is the difference between the Exports(as % of merchandise exports) in Pacific island small states and Exports(as % of merchandise exports) in Singapore?
Keep it short and to the point. -40.86. In the year 2011, what is the difference between the Exports(as % of merchandise exports) of Croatia and Exports(as % of merchandise exports) of Senegal?
Ensure brevity in your answer.  22.83. In the year 2011, what is the difference between the Exports(as % of merchandise exports) of Croatia and Exports(as % of merchandise exports) of Singapore?
Give a very brief answer. -1.73. In the year 2011, what is the difference between the Exports(as % of merchandise exports) in Senegal and Exports(as % of merchandise exports) in Singapore?
Your answer should be compact. -24.56. In the year 2012, what is the difference between the Exports(as % of merchandise exports) of Pacific island small states and Exports(as % of merchandise exports) of Croatia?
Make the answer very short. -33.65. In the year 2012, what is the difference between the Exports(as % of merchandise exports) in Pacific island small states and Exports(as % of merchandise exports) in Senegal?
Your answer should be compact. -15.78. In the year 2012, what is the difference between the Exports(as % of merchandise exports) of Pacific island small states and Exports(as % of merchandise exports) of Singapore?
Offer a very short reply. -40.1. In the year 2012, what is the difference between the Exports(as % of merchandise exports) in Croatia and Exports(as % of merchandise exports) in Senegal?
Your answer should be compact. 17.87. In the year 2012, what is the difference between the Exports(as % of merchandise exports) of Croatia and Exports(as % of merchandise exports) of Singapore?
Offer a very short reply. -6.45. In the year 2012, what is the difference between the Exports(as % of merchandise exports) of Senegal and Exports(as % of merchandise exports) of Singapore?
Your answer should be very brief. -24.32. What is the ratio of the Exports(as % of merchandise exports) in Pacific island small states in 2005 to that in 2006?
Make the answer very short. 1.15. What is the ratio of the Exports(as % of merchandise exports) in Croatia in 2005 to that in 2006?
Offer a very short reply. 1.04. What is the ratio of the Exports(as % of merchandise exports) of Senegal in 2005 to that in 2006?
Provide a succinct answer. 0.99. What is the ratio of the Exports(as % of merchandise exports) of Singapore in 2005 to that in 2006?
Ensure brevity in your answer.  1.02. What is the ratio of the Exports(as % of merchandise exports) in Pacific island small states in 2005 to that in 2007?
Give a very brief answer. 1.06. What is the ratio of the Exports(as % of merchandise exports) in Croatia in 2005 to that in 2007?
Offer a terse response. 1. What is the ratio of the Exports(as % of merchandise exports) in Senegal in 2005 to that in 2007?
Offer a terse response. 1.19. What is the ratio of the Exports(as % of merchandise exports) in Singapore in 2005 to that in 2007?
Your answer should be very brief. 1.06. What is the ratio of the Exports(as % of merchandise exports) in Pacific island small states in 2005 to that in 2008?
Offer a terse response. 1.13. What is the ratio of the Exports(as % of merchandise exports) in Croatia in 2005 to that in 2008?
Give a very brief answer. 0.98. What is the ratio of the Exports(as % of merchandise exports) of Senegal in 2005 to that in 2008?
Make the answer very short. 1.11. What is the ratio of the Exports(as % of merchandise exports) in Singapore in 2005 to that in 2008?
Offer a very short reply. 1.15. What is the ratio of the Exports(as % of merchandise exports) of Pacific island small states in 2005 to that in 2009?
Your answer should be compact. 1.21. What is the ratio of the Exports(as % of merchandise exports) of Croatia in 2005 to that in 2009?
Offer a terse response. 1.03. What is the ratio of the Exports(as % of merchandise exports) of Senegal in 2005 to that in 2009?
Offer a terse response. 1.05. What is the ratio of the Exports(as % of merchandise exports) of Singapore in 2005 to that in 2009?
Make the answer very short. 1.09. What is the ratio of the Exports(as % of merchandise exports) of Pacific island small states in 2005 to that in 2010?
Your answer should be compact. 1.03. What is the ratio of the Exports(as % of merchandise exports) in Croatia in 2005 to that in 2010?
Ensure brevity in your answer.  1.01. What is the ratio of the Exports(as % of merchandise exports) in Senegal in 2005 to that in 2010?
Offer a terse response. 1.08. What is the ratio of the Exports(as % of merchandise exports) in Singapore in 2005 to that in 2010?
Give a very brief answer. 1.11. What is the ratio of the Exports(as % of merchandise exports) in Pacific island small states in 2005 to that in 2011?
Ensure brevity in your answer.  1.26. What is the ratio of the Exports(as % of merchandise exports) of Croatia in 2005 to that in 2011?
Your answer should be compact. 1.02. What is the ratio of the Exports(as % of merchandise exports) in Senegal in 2005 to that in 2011?
Provide a short and direct response. 0.98. What is the ratio of the Exports(as % of merchandise exports) in Singapore in 2005 to that in 2011?
Keep it short and to the point. 1.18. What is the ratio of the Exports(as % of merchandise exports) in Pacific island small states in 2005 to that in 2012?
Provide a short and direct response. 1.18. What is the ratio of the Exports(as % of merchandise exports) of Croatia in 2005 to that in 2012?
Provide a short and direct response. 1.08. What is the ratio of the Exports(as % of merchandise exports) of Senegal in 2005 to that in 2012?
Offer a very short reply. 0.96. What is the ratio of the Exports(as % of merchandise exports) of Singapore in 2005 to that in 2012?
Provide a short and direct response. 1.16. What is the ratio of the Exports(as % of merchandise exports) of Pacific island small states in 2006 to that in 2007?
Your answer should be compact. 0.92. What is the ratio of the Exports(as % of merchandise exports) in Croatia in 2006 to that in 2007?
Keep it short and to the point. 0.96. What is the ratio of the Exports(as % of merchandise exports) of Senegal in 2006 to that in 2007?
Offer a terse response. 1.21. What is the ratio of the Exports(as % of merchandise exports) in Singapore in 2006 to that in 2007?
Your response must be concise. 1.04. What is the ratio of the Exports(as % of merchandise exports) in Pacific island small states in 2006 to that in 2008?
Offer a terse response. 0.98. What is the ratio of the Exports(as % of merchandise exports) of Croatia in 2006 to that in 2008?
Offer a very short reply. 0.94. What is the ratio of the Exports(as % of merchandise exports) in Senegal in 2006 to that in 2008?
Your answer should be compact. 1.12. What is the ratio of the Exports(as % of merchandise exports) of Singapore in 2006 to that in 2008?
Your response must be concise. 1.13. What is the ratio of the Exports(as % of merchandise exports) in Pacific island small states in 2006 to that in 2009?
Your answer should be very brief. 1.05. What is the ratio of the Exports(as % of merchandise exports) in Croatia in 2006 to that in 2009?
Keep it short and to the point. 0.99. What is the ratio of the Exports(as % of merchandise exports) in Senegal in 2006 to that in 2009?
Give a very brief answer. 1.07. What is the ratio of the Exports(as % of merchandise exports) in Singapore in 2006 to that in 2009?
Give a very brief answer. 1.07. What is the ratio of the Exports(as % of merchandise exports) of Pacific island small states in 2006 to that in 2010?
Your response must be concise. 0.9. What is the ratio of the Exports(as % of merchandise exports) in Croatia in 2006 to that in 2010?
Offer a terse response. 0.97. What is the ratio of the Exports(as % of merchandise exports) in Senegal in 2006 to that in 2010?
Give a very brief answer. 1.1. What is the ratio of the Exports(as % of merchandise exports) of Singapore in 2006 to that in 2010?
Give a very brief answer. 1.09. What is the ratio of the Exports(as % of merchandise exports) in Pacific island small states in 2006 to that in 2011?
Your response must be concise. 1.1. What is the ratio of the Exports(as % of merchandise exports) in Croatia in 2006 to that in 2011?
Ensure brevity in your answer.  0.98. What is the ratio of the Exports(as % of merchandise exports) of Senegal in 2006 to that in 2011?
Provide a short and direct response. 1. What is the ratio of the Exports(as % of merchandise exports) of Singapore in 2006 to that in 2011?
Your answer should be compact. 1.16. What is the ratio of the Exports(as % of merchandise exports) in Pacific island small states in 2006 to that in 2012?
Provide a succinct answer. 1.03. What is the ratio of the Exports(as % of merchandise exports) in Croatia in 2006 to that in 2012?
Make the answer very short. 1.04. What is the ratio of the Exports(as % of merchandise exports) of Senegal in 2006 to that in 2012?
Ensure brevity in your answer.  0.97. What is the ratio of the Exports(as % of merchandise exports) of Singapore in 2006 to that in 2012?
Provide a succinct answer. 1.14. What is the ratio of the Exports(as % of merchandise exports) of Pacific island small states in 2007 to that in 2008?
Provide a short and direct response. 1.06. What is the ratio of the Exports(as % of merchandise exports) of Croatia in 2007 to that in 2008?
Offer a very short reply. 0.98. What is the ratio of the Exports(as % of merchandise exports) of Senegal in 2007 to that in 2008?
Your answer should be very brief. 0.93. What is the ratio of the Exports(as % of merchandise exports) in Singapore in 2007 to that in 2008?
Your answer should be very brief. 1.08. What is the ratio of the Exports(as % of merchandise exports) of Pacific island small states in 2007 to that in 2009?
Provide a short and direct response. 1.14. What is the ratio of the Exports(as % of merchandise exports) of Croatia in 2007 to that in 2009?
Provide a short and direct response. 1.03. What is the ratio of the Exports(as % of merchandise exports) in Senegal in 2007 to that in 2009?
Give a very brief answer. 0.88. What is the ratio of the Exports(as % of merchandise exports) of Singapore in 2007 to that in 2009?
Offer a terse response. 1.03. What is the ratio of the Exports(as % of merchandise exports) in Pacific island small states in 2007 to that in 2010?
Provide a short and direct response. 0.97. What is the ratio of the Exports(as % of merchandise exports) in Senegal in 2007 to that in 2010?
Offer a terse response. 0.91. What is the ratio of the Exports(as % of merchandise exports) in Singapore in 2007 to that in 2010?
Make the answer very short. 1.04. What is the ratio of the Exports(as % of merchandise exports) in Pacific island small states in 2007 to that in 2011?
Your response must be concise. 1.19. What is the ratio of the Exports(as % of merchandise exports) of Croatia in 2007 to that in 2011?
Ensure brevity in your answer.  1.02. What is the ratio of the Exports(as % of merchandise exports) in Senegal in 2007 to that in 2011?
Offer a very short reply. 0.82. What is the ratio of the Exports(as % of merchandise exports) of Singapore in 2007 to that in 2011?
Ensure brevity in your answer.  1.11. What is the ratio of the Exports(as % of merchandise exports) of Croatia in 2007 to that in 2012?
Give a very brief answer. 1.08. What is the ratio of the Exports(as % of merchandise exports) in Senegal in 2007 to that in 2012?
Ensure brevity in your answer.  0.8. What is the ratio of the Exports(as % of merchandise exports) of Singapore in 2007 to that in 2012?
Your response must be concise. 1.09. What is the ratio of the Exports(as % of merchandise exports) of Pacific island small states in 2008 to that in 2009?
Your response must be concise. 1.08. What is the ratio of the Exports(as % of merchandise exports) of Croatia in 2008 to that in 2009?
Offer a very short reply. 1.05. What is the ratio of the Exports(as % of merchandise exports) in Senegal in 2008 to that in 2009?
Keep it short and to the point. 0.95. What is the ratio of the Exports(as % of merchandise exports) in Singapore in 2008 to that in 2009?
Provide a succinct answer. 0.95. What is the ratio of the Exports(as % of merchandise exports) in Pacific island small states in 2008 to that in 2010?
Provide a succinct answer. 0.92. What is the ratio of the Exports(as % of merchandise exports) of Croatia in 2008 to that in 2010?
Your response must be concise. 1.03. What is the ratio of the Exports(as % of merchandise exports) of Senegal in 2008 to that in 2010?
Offer a very short reply. 0.98. What is the ratio of the Exports(as % of merchandise exports) of Singapore in 2008 to that in 2010?
Your response must be concise. 0.96. What is the ratio of the Exports(as % of merchandise exports) of Pacific island small states in 2008 to that in 2011?
Make the answer very short. 1.12. What is the ratio of the Exports(as % of merchandise exports) in Croatia in 2008 to that in 2011?
Your answer should be very brief. 1.04. What is the ratio of the Exports(as % of merchandise exports) in Senegal in 2008 to that in 2011?
Your response must be concise. 0.89. What is the ratio of the Exports(as % of merchandise exports) in Singapore in 2008 to that in 2011?
Provide a succinct answer. 1.03. What is the ratio of the Exports(as % of merchandise exports) in Pacific island small states in 2008 to that in 2012?
Give a very brief answer. 1.05. What is the ratio of the Exports(as % of merchandise exports) in Croatia in 2008 to that in 2012?
Offer a very short reply. 1.1. What is the ratio of the Exports(as % of merchandise exports) in Senegal in 2008 to that in 2012?
Your answer should be very brief. 0.86. What is the ratio of the Exports(as % of merchandise exports) of Singapore in 2008 to that in 2012?
Keep it short and to the point. 1.01. What is the ratio of the Exports(as % of merchandise exports) of Pacific island small states in 2009 to that in 2010?
Offer a very short reply. 0.85. What is the ratio of the Exports(as % of merchandise exports) of Croatia in 2009 to that in 2010?
Give a very brief answer. 0.98. What is the ratio of the Exports(as % of merchandise exports) of Senegal in 2009 to that in 2010?
Give a very brief answer. 1.03. What is the ratio of the Exports(as % of merchandise exports) in Singapore in 2009 to that in 2010?
Keep it short and to the point. 1.01. What is the ratio of the Exports(as % of merchandise exports) of Pacific island small states in 2009 to that in 2011?
Make the answer very short. 1.04. What is the ratio of the Exports(as % of merchandise exports) of Croatia in 2009 to that in 2011?
Keep it short and to the point. 0.99. What is the ratio of the Exports(as % of merchandise exports) of Senegal in 2009 to that in 2011?
Make the answer very short. 0.94. What is the ratio of the Exports(as % of merchandise exports) in Singapore in 2009 to that in 2011?
Make the answer very short. 1.08. What is the ratio of the Exports(as % of merchandise exports) in Pacific island small states in 2009 to that in 2012?
Provide a short and direct response. 0.98. What is the ratio of the Exports(as % of merchandise exports) of Croatia in 2009 to that in 2012?
Your response must be concise. 1.05. What is the ratio of the Exports(as % of merchandise exports) in Senegal in 2009 to that in 2012?
Ensure brevity in your answer.  0.91. What is the ratio of the Exports(as % of merchandise exports) in Singapore in 2009 to that in 2012?
Ensure brevity in your answer.  1.06. What is the ratio of the Exports(as % of merchandise exports) of Pacific island small states in 2010 to that in 2011?
Give a very brief answer. 1.22. What is the ratio of the Exports(as % of merchandise exports) in Croatia in 2010 to that in 2011?
Make the answer very short. 1.01. What is the ratio of the Exports(as % of merchandise exports) in Senegal in 2010 to that in 2011?
Provide a short and direct response. 0.91. What is the ratio of the Exports(as % of merchandise exports) in Singapore in 2010 to that in 2011?
Offer a very short reply. 1.06. What is the ratio of the Exports(as % of merchandise exports) of Pacific island small states in 2010 to that in 2012?
Offer a very short reply. 1.14. What is the ratio of the Exports(as % of merchandise exports) in Croatia in 2010 to that in 2012?
Your response must be concise. 1.07. What is the ratio of the Exports(as % of merchandise exports) of Senegal in 2010 to that in 2012?
Ensure brevity in your answer.  0.88. What is the ratio of the Exports(as % of merchandise exports) in Singapore in 2010 to that in 2012?
Make the answer very short. 1.05. What is the ratio of the Exports(as % of merchandise exports) in Pacific island small states in 2011 to that in 2012?
Provide a succinct answer. 0.94. What is the ratio of the Exports(as % of merchandise exports) in Croatia in 2011 to that in 2012?
Your answer should be very brief. 1.06. What is the ratio of the Exports(as % of merchandise exports) of Senegal in 2011 to that in 2012?
Your answer should be compact. 0.97. What is the ratio of the Exports(as % of merchandise exports) in Singapore in 2011 to that in 2012?
Your answer should be very brief. 0.98. What is the difference between the highest and the second highest Exports(as % of merchandise exports) in Pacific island small states?
Offer a terse response. 1.17. What is the difference between the highest and the second highest Exports(as % of merchandise exports) of Croatia?
Your answer should be very brief. 1.3. What is the difference between the highest and the second highest Exports(as % of merchandise exports) in Senegal?
Give a very brief answer. 1.33. What is the difference between the highest and the second highest Exports(as % of merchandise exports) of Singapore?
Provide a short and direct response. 1.62. What is the difference between the highest and the lowest Exports(as % of merchandise exports) in Pacific island small states?
Your answer should be very brief. 7.26. What is the difference between the highest and the lowest Exports(as % of merchandise exports) in Croatia?
Your response must be concise. 6.31. What is the difference between the highest and the lowest Exports(as % of merchandise exports) in Senegal?
Provide a succinct answer. 9.09. What is the difference between the highest and the lowest Exports(as % of merchandise exports) of Singapore?
Offer a terse response. 12.47. 